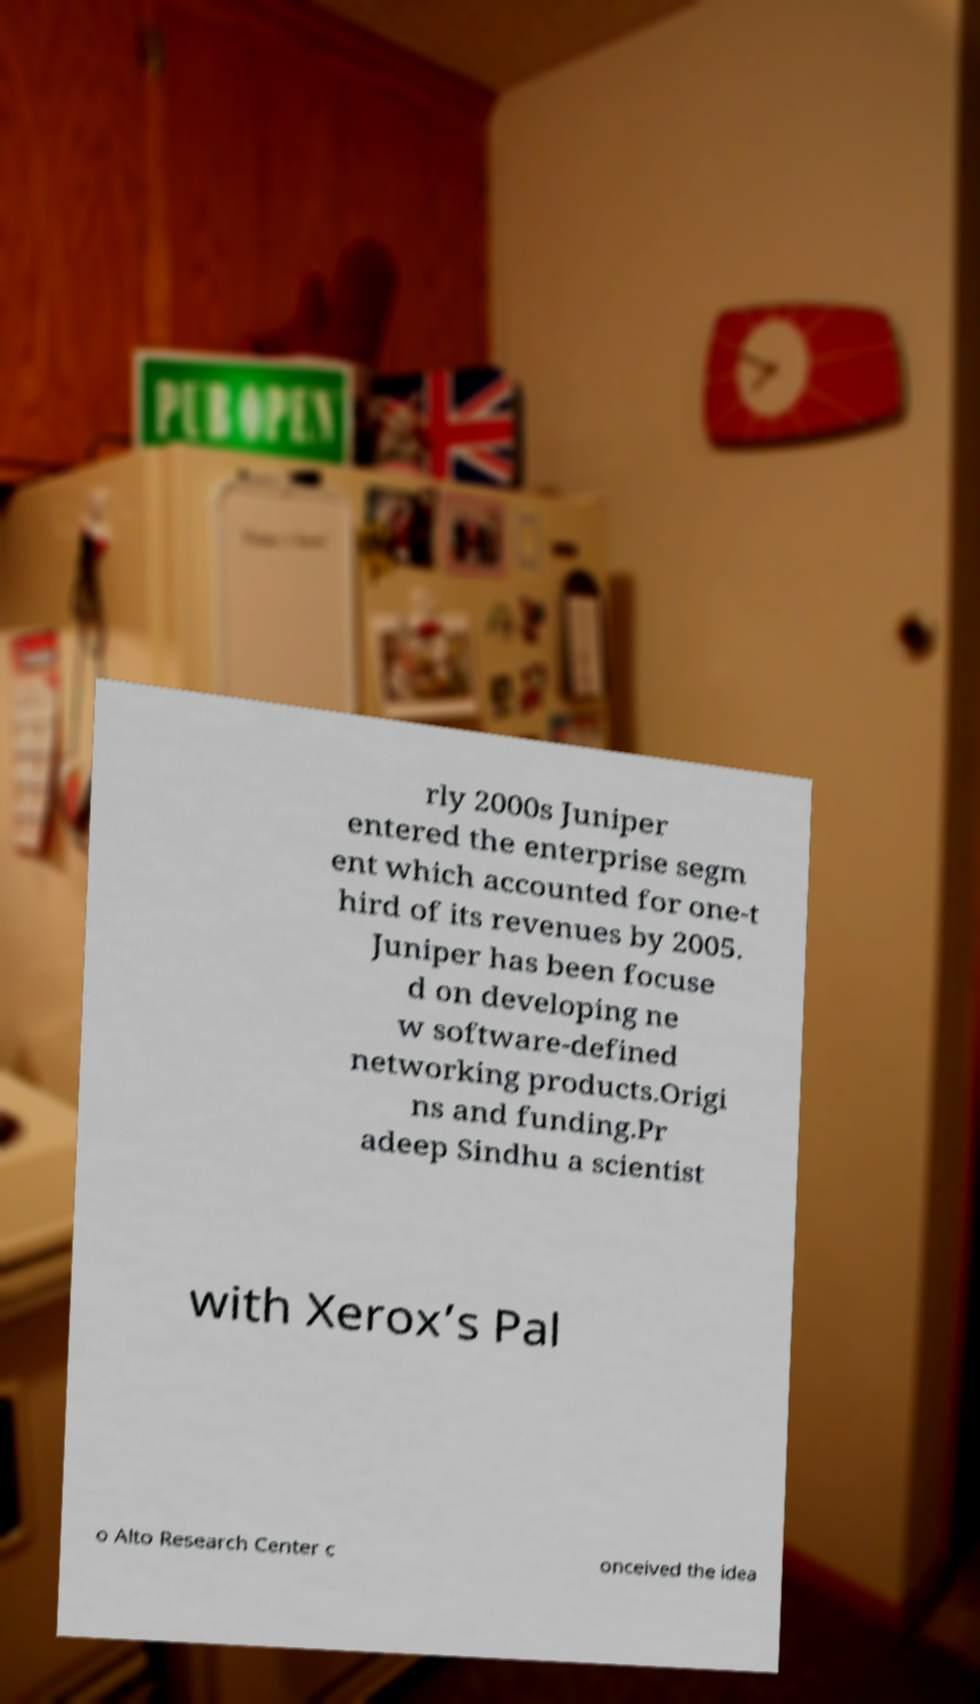What messages or text are displayed in this image? I need them in a readable, typed format. rly 2000s Juniper entered the enterprise segm ent which accounted for one-t hird of its revenues by 2005. Juniper has been focuse d on developing ne w software-defined networking products.Origi ns and funding.Pr adeep Sindhu a scientist with Xerox’s Pal o Alto Research Center c onceived the idea 